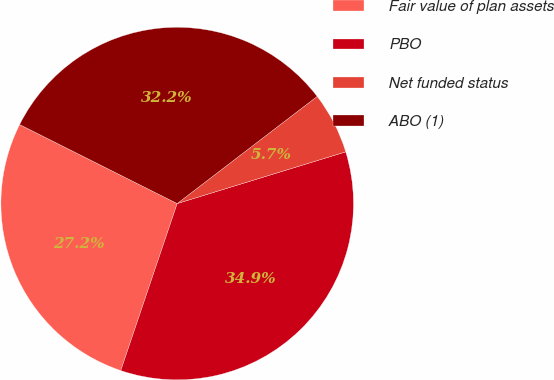Convert chart. <chart><loc_0><loc_0><loc_500><loc_500><pie_chart><fcel>Fair value of plan assets<fcel>PBO<fcel>Net funded status<fcel>ABO (1)<nl><fcel>27.21%<fcel>34.92%<fcel>5.66%<fcel>32.2%<nl></chart> 